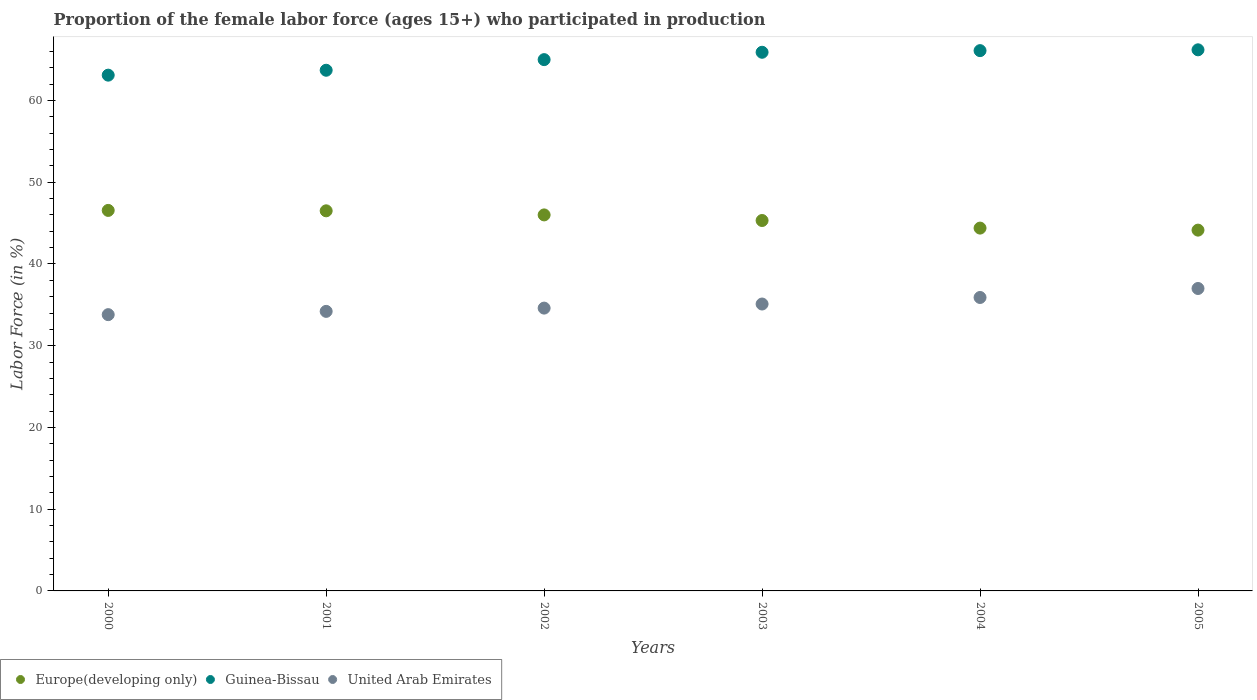What is the proportion of the female labor force who participated in production in Europe(developing only) in 2003?
Offer a terse response. 45.32. Across all years, what is the maximum proportion of the female labor force who participated in production in Europe(developing only)?
Give a very brief answer. 46.55. Across all years, what is the minimum proportion of the female labor force who participated in production in Europe(developing only)?
Make the answer very short. 44.14. In which year was the proportion of the female labor force who participated in production in Guinea-Bissau maximum?
Offer a very short reply. 2005. In which year was the proportion of the female labor force who participated in production in Guinea-Bissau minimum?
Ensure brevity in your answer.  2000. What is the total proportion of the female labor force who participated in production in Europe(developing only) in the graph?
Offer a very short reply. 272.9. What is the difference between the proportion of the female labor force who participated in production in Guinea-Bissau in 2003 and that in 2004?
Provide a succinct answer. -0.2. What is the difference between the proportion of the female labor force who participated in production in Europe(developing only) in 2004 and the proportion of the female labor force who participated in production in Guinea-Bissau in 2005?
Your answer should be very brief. -21.81. What is the average proportion of the female labor force who participated in production in Europe(developing only) per year?
Your answer should be very brief. 45.48. In the year 2002, what is the difference between the proportion of the female labor force who participated in production in Guinea-Bissau and proportion of the female labor force who participated in production in Europe(developing only)?
Offer a very short reply. 19. What is the ratio of the proportion of the female labor force who participated in production in Europe(developing only) in 2002 to that in 2003?
Your answer should be very brief. 1.02. Is the difference between the proportion of the female labor force who participated in production in Guinea-Bissau in 2002 and 2004 greater than the difference between the proportion of the female labor force who participated in production in Europe(developing only) in 2002 and 2004?
Your answer should be very brief. No. What is the difference between the highest and the second highest proportion of the female labor force who participated in production in Europe(developing only)?
Provide a short and direct response. 0.05. What is the difference between the highest and the lowest proportion of the female labor force who participated in production in Guinea-Bissau?
Your answer should be compact. 3.1. Is the sum of the proportion of the female labor force who participated in production in Guinea-Bissau in 2003 and 2005 greater than the maximum proportion of the female labor force who participated in production in United Arab Emirates across all years?
Give a very brief answer. Yes. Is it the case that in every year, the sum of the proportion of the female labor force who participated in production in Europe(developing only) and proportion of the female labor force who participated in production in Guinea-Bissau  is greater than the proportion of the female labor force who participated in production in United Arab Emirates?
Ensure brevity in your answer.  Yes. Is the proportion of the female labor force who participated in production in Guinea-Bissau strictly greater than the proportion of the female labor force who participated in production in Europe(developing only) over the years?
Offer a very short reply. Yes. How many dotlines are there?
Provide a succinct answer. 3. What is the difference between two consecutive major ticks on the Y-axis?
Your response must be concise. 10. Are the values on the major ticks of Y-axis written in scientific E-notation?
Keep it short and to the point. No. Does the graph contain any zero values?
Provide a short and direct response. No. Where does the legend appear in the graph?
Make the answer very short. Bottom left. What is the title of the graph?
Offer a terse response. Proportion of the female labor force (ages 15+) who participated in production. What is the Labor Force (in %) in Europe(developing only) in 2000?
Your answer should be very brief. 46.55. What is the Labor Force (in %) of Guinea-Bissau in 2000?
Your answer should be very brief. 63.1. What is the Labor Force (in %) of United Arab Emirates in 2000?
Your answer should be compact. 33.8. What is the Labor Force (in %) of Europe(developing only) in 2001?
Keep it short and to the point. 46.5. What is the Labor Force (in %) in Guinea-Bissau in 2001?
Offer a terse response. 63.7. What is the Labor Force (in %) of United Arab Emirates in 2001?
Keep it short and to the point. 34.2. What is the Labor Force (in %) in Europe(developing only) in 2002?
Give a very brief answer. 46. What is the Labor Force (in %) in United Arab Emirates in 2002?
Your answer should be compact. 34.6. What is the Labor Force (in %) in Europe(developing only) in 2003?
Ensure brevity in your answer.  45.32. What is the Labor Force (in %) of Guinea-Bissau in 2003?
Offer a very short reply. 65.9. What is the Labor Force (in %) of United Arab Emirates in 2003?
Ensure brevity in your answer.  35.1. What is the Labor Force (in %) in Europe(developing only) in 2004?
Your answer should be very brief. 44.39. What is the Labor Force (in %) in Guinea-Bissau in 2004?
Your answer should be very brief. 66.1. What is the Labor Force (in %) of United Arab Emirates in 2004?
Provide a short and direct response. 35.9. What is the Labor Force (in %) in Europe(developing only) in 2005?
Keep it short and to the point. 44.14. What is the Labor Force (in %) in Guinea-Bissau in 2005?
Offer a very short reply. 66.2. Across all years, what is the maximum Labor Force (in %) in Europe(developing only)?
Your response must be concise. 46.55. Across all years, what is the maximum Labor Force (in %) in Guinea-Bissau?
Make the answer very short. 66.2. Across all years, what is the maximum Labor Force (in %) in United Arab Emirates?
Your answer should be compact. 37. Across all years, what is the minimum Labor Force (in %) in Europe(developing only)?
Provide a short and direct response. 44.14. Across all years, what is the minimum Labor Force (in %) of Guinea-Bissau?
Ensure brevity in your answer.  63.1. Across all years, what is the minimum Labor Force (in %) of United Arab Emirates?
Your answer should be compact. 33.8. What is the total Labor Force (in %) of Europe(developing only) in the graph?
Make the answer very short. 272.9. What is the total Labor Force (in %) of Guinea-Bissau in the graph?
Offer a terse response. 390. What is the total Labor Force (in %) of United Arab Emirates in the graph?
Keep it short and to the point. 210.6. What is the difference between the Labor Force (in %) of Europe(developing only) in 2000 and that in 2001?
Provide a succinct answer. 0.05. What is the difference between the Labor Force (in %) in Guinea-Bissau in 2000 and that in 2001?
Make the answer very short. -0.6. What is the difference between the Labor Force (in %) of United Arab Emirates in 2000 and that in 2001?
Provide a succinct answer. -0.4. What is the difference between the Labor Force (in %) of Europe(developing only) in 2000 and that in 2002?
Ensure brevity in your answer.  0.55. What is the difference between the Labor Force (in %) of Europe(developing only) in 2000 and that in 2003?
Offer a very short reply. 1.24. What is the difference between the Labor Force (in %) of Europe(developing only) in 2000 and that in 2004?
Offer a very short reply. 2.16. What is the difference between the Labor Force (in %) in United Arab Emirates in 2000 and that in 2004?
Ensure brevity in your answer.  -2.1. What is the difference between the Labor Force (in %) in Europe(developing only) in 2000 and that in 2005?
Ensure brevity in your answer.  2.41. What is the difference between the Labor Force (in %) in Guinea-Bissau in 2000 and that in 2005?
Keep it short and to the point. -3.1. What is the difference between the Labor Force (in %) of Europe(developing only) in 2001 and that in 2002?
Your answer should be compact. 0.5. What is the difference between the Labor Force (in %) in Guinea-Bissau in 2001 and that in 2002?
Keep it short and to the point. -1.3. What is the difference between the Labor Force (in %) in United Arab Emirates in 2001 and that in 2002?
Offer a very short reply. -0.4. What is the difference between the Labor Force (in %) in Europe(developing only) in 2001 and that in 2003?
Provide a succinct answer. 1.19. What is the difference between the Labor Force (in %) of Guinea-Bissau in 2001 and that in 2003?
Provide a succinct answer. -2.2. What is the difference between the Labor Force (in %) in Europe(developing only) in 2001 and that in 2004?
Offer a very short reply. 2.11. What is the difference between the Labor Force (in %) of United Arab Emirates in 2001 and that in 2004?
Provide a succinct answer. -1.7. What is the difference between the Labor Force (in %) in Europe(developing only) in 2001 and that in 2005?
Give a very brief answer. 2.36. What is the difference between the Labor Force (in %) of United Arab Emirates in 2001 and that in 2005?
Offer a very short reply. -2.8. What is the difference between the Labor Force (in %) of Europe(developing only) in 2002 and that in 2003?
Your response must be concise. 0.69. What is the difference between the Labor Force (in %) of Europe(developing only) in 2002 and that in 2004?
Your answer should be compact. 1.61. What is the difference between the Labor Force (in %) of Guinea-Bissau in 2002 and that in 2004?
Give a very brief answer. -1.1. What is the difference between the Labor Force (in %) in United Arab Emirates in 2002 and that in 2004?
Provide a short and direct response. -1.3. What is the difference between the Labor Force (in %) in Europe(developing only) in 2002 and that in 2005?
Keep it short and to the point. 1.86. What is the difference between the Labor Force (in %) in Guinea-Bissau in 2002 and that in 2005?
Provide a succinct answer. -1.2. What is the difference between the Labor Force (in %) in Europe(developing only) in 2003 and that in 2004?
Your answer should be very brief. 0.93. What is the difference between the Labor Force (in %) of Guinea-Bissau in 2003 and that in 2004?
Your answer should be very brief. -0.2. What is the difference between the Labor Force (in %) of United Arab Emirates in 2003 and that in 2004?
Offer a very short reply. -0.8. What is the difference between the Labor Force (in %) of Europe(developing only) in 2003 and that in 2005?
Your answer should be compact. 1.18. What is the difference between the Labor Force (in %) of Europe(developing only) in 2004 and that in 2005?
Provide a short and direct response. 0.25. What is the difference between the Labor Force (in %) in Guinea-Bissau in 2004 and that in 2005?
Provide a short and direct response. -0.1. What is the difference between the Labor Force (in %) in Europe(developing only) in 2000 and the Labor Force (in %) in Guinea-Bissau in 2001?
Provide a short and direct response. -17.15. What is the difference between the Labor Force (in %) of Europe(developing only) in 2000 and the Labor Force (in %) of United Arab Emirates in 2001?
Your answer should be compact. 12.35. What is the difference between the Labor Force (in %) in Guinea-Bissau in 2000 and the Labor Force (in %) in United Arab Emirates in 2001?
Offer a very short reply. 28.9. What is the difference between the Labor Force (in %) in Europe(developing only) in 2000 and the Labor Force (in %) in Guinea-Bissau in 2002?
Keep it short and to the point. -18.45. What is the difference between the Labor Force (in %) in Europe(developing only) in 2000 and the Labor Force (in %) in United Arab Emirates in 2002?
Ensure brevity in your answer.  11.95. What is the difference between the Labor Force (in %) of Guinea-Bissau in 2000 and the Labor Force (in %) of United Arab Emirates in 2002?
Provide a succinct answer. 28.5. What is the difference between the Labor Force (in %) in Europe(developing only) in 2000 and the Labor Force (in %) in Guinea-Bissau in 2003?
Give a very brief answer. -19.35. What is the difference between the Labor Force (in %) of Europe(developing only) in 2000 and the Labor Force (in %) of United Arab Emirates in 2003?
Keep it short and to the point. 11.45. What is the difference between the Labor Force (in %) in Europe(developing only) in 2000 and the Labor Force (in %) in Guinea-Bissau in 2004?
Provide a short and direct response. -19.55. What is the difference between the Labor Force (in %) in Europe(developing only) in 2000 and the Labor Force (in %) in United Arab Emirates in 2004?
Offer a very short reply. 10.65. What is the difference between the Labor Force (in %) in Guinea-Bissau in 2000 and the Labor Force (in %) in United Arab Emirates in 2004?
Your response must be concise. 27.2. What is the difference between the Labor Force (in %) in Europe(developing only) in 2000 and the Labor Force (in %) in Guinea-Bissau in 2005?
Make the answer very short. -19.65. What is the difference between the Labor Force (in %) in Europe(developing only) in 2000 and the Labor Force (in %) in United Arab Emirates in 2005?
Keep it short and to the point. 9.55. What is the difference between the Labor Force (in %) in Guinea-Bissau in 2000 and the Labor Force (in %) in United Arab Emirates in 2005?
Provide a succinct answer. 26.1. What is the difference between the Labor Force (in %) in Europe(developing only) in 2001 and the Labor Force (in %) in Guinea-Bissau in 2002?
Your answer should be very brief. -18.5. What is the difference between the Labor Force (in %) of Europe(developing only) in 2001 and the Labor Force (in %) of United Arab Emirates in 2002?
Provide a short and direct response. 11.9. What is the difference between the Labor Force (in %) in Guinea-Bissau in 2001 and the Labor Force (in %) in United Arab Emirates in 2002?
Provide a succinct answer. 29.1. What is the difference between the Labor Force (in %) of Europe(developing only) in 2001 and the Labor Force (in %) of Guinea-Bissau in 2003?
Make the answer very short. -19.4. What is the difference between the Labor Force (in %) in Europe(developing only) in 2001 and the Labor Force (in %) in United Arab Emirates in 2003?
Your answer should be compact. 11.4. What is the difference between the Labor Force (in %) in Guinea-Bissau in 2001 and the Labor Force (in %) in United Arab Emirates in 2003?
Offer a terse response. 28.6. What is the difference between the Labor Force (in %) of Europe(developing only) in 2001 and the Labor Force (in %) of Guinea-Bissau in 2004?
Your answer should be very brief. -19.6. What is the difference between the Labor Force (in %) of Europe(developing only) in 2001 and the Labor Force (in %) of United Arab Emirates in 2004?
Make the answer very short. 10.6. What is the difference between the Labor Force (in %) of Guinea-Bissau in 2001 and the Labor Force (in %) of United Arab Emirates in 2004?
Your response must be concise. 27.8. What is the difference between the Labor Force (in %) in Europe(developing only) in 2001 and the Labor Force (in %) in Guinea-Bissau in 2005?
Offer a very short reply. -19.7. What is the difference between the Labor Force (in %) in Europe(developing only) in 2001 and the Labor Force (in %) in United Arab Emirates in 2005?
Offer a very short reply. 9.5. What is the difference between the Labor Force (in %) of Guinea-Bissau in 2001 and the Labor Force (in %) of United Arab Emirates in 2005?
Give a very brief answer. 26.7. What is the difference between the Labor Force (in %) in Europe(developing only) in 2002 and the Labor Force (in %) in Guinea-Bissau in 2003?
Provide a short and direct response. -19.9. What is the difference between the Labor Force (in %) of Europe(developing only) in 2002 and the Labor Force (in %) of United Arab Emirates in 2003?
Provide a succinct answer. 10.9. What is the difference between the Labor Force (in %) in Guinea-Bissau in 2002 and the Labor Force (in %) in United Arab Emirates in 2003?
Your response must be concise. 29.9. What is the difference between the Labor Force (in %) in Europe(developing only) in 2002 and the Labor Force (in %) in Guinea-Bissau in 2004?
Make the answer very short. -20.1. What is the difference between the Labor Force (in %) of Europe(developing only) in 2002 and the Labor Force (in %) of United Arab Emirates in 2004?
Offer a terse response. 10.1. What is the difference between the Labor Force (in %) in Guinea-Bissau in 2002 and the Labor Force (in %) in United Arab Emirates in 2004?
Make the answer very short. 29.1. What is the difference between the Labor Force (in %) of Europe(developing only) in 2002 and the Labor Force (in %) of Guinea-Bissau in 2005?
Offer a very short reply. -20.2. What is the difference between the Labor Force (in %) of Europe(developing only) in 2002 and the Labor Force (in %) of United Arab Emirates in 2005?
Give a very brief answer. 9. What is the difference between the Labor Force (in %) in Guinea-Bissau in 2002 and the Labor Force (in %) in United Arab Emirates in 2005?
Provide a succinct answer. 28. What is the difference between the Labor Force (in %) of Europe(developing only) in 2003 and the Labor Force (in %) of Guinea-Bissau in 2004?
Your response must be concise. -20.78. What is the difference between the Labor Force (in %) of Europe(developing only) in 2003 and the Labor Force (in %) of United Arab Emirates in 2004?
Offer a terse response. 9.42. What is the difference between the Labor Force (in %) in Guinea-Bissau in 2003 and the Labor Force (in %) in United Arab Emirates in 2004?
Provide a short and direct response. 30. What is the difference between the Labor Force (in %) in Europe(developing only) in 2003 and the Labor Force (in %) in Guinea-Bissau in 2005?
Offer a terse response. -20.88. What is the difference between the Labor Force (in %) of Europe(developing only) in 2003 and the Labor Force (in %) of United Arab Emirates in 2005?
Ensure brevity in your answer.  8.32. What is the difference between the Labor Force (in %) in Guinea-Bissau in 2003 and the Labor Force (in %) in United Arab Emirates in 2005?
Your response must be concise. 28.9. What is the difference between the Labor Force (in %) of Europe(developing only) in 2004 and the Labor Force (in %) of Guinea-Bissau in 2005?
Give a very brief answer. -21.81. What is the difference between the Labor Force (in %) of Europe(developing only) in 2004 and the Labor Force (in %) of United Arab Emirates in 2005?
Provide a succinct answer. 7.39. What is the difference between the Labor Force (in %) in Guinea-Bissau in 2004 and the Labor Force (in %) in United Arab Emirates in 2005?
Keep it short and to the point. 29.1. What is the average Labor Force (in %) in Europe(developing only) per year?
Offer a terse response. 45.48. What is the average Labor Force (in %) of Guinea-Bissau per year?
Make the answer very short. 65. What is the average Labor Force (in %) of United Arab Emirates per year?
Keep it short and to the point. 35.1. In the year 2000, what is the difference between the Labor Force (in %) of Europe(developing only) and Labor Force (in %) of Guinea-Bissau?
Your response must be concise. -16.55. In the year 2000, what is the difference between the Labor Force (in %) in Europe(developing only) and Labor Force (in %) in United Arab Emirates?
Offer a terse response. 12.75. In the year 2000, what is the difference between the Labor Force (in %) of Guinea-Bissau and Labor Force (in %) of United Arab Emirates?
Offer a very short reply. 29.3. In the year 2001, what is the difference between the Labor Force (in %) in Europe(developing only) and Labor Force (in %) in Guinea-Bissau?
Give a very brief answer. -17.2. In the year 2001, what is the difference between the Labor Force (in %) in Europe(developing only) and Labor Force (in %) in United Arab Emirates?
Your answer should be very brief. 12.3. In the year 2001, what is the difference between the Labor Force (in %) of Guinea-Bissau and Labor Force (in %) of United Arab Emirates?
Offer a very short reply. 29.5. In the year 2002, what is the difference between the Labor Force (in %) in Europe(developing only) and Labor Force (in %) in Guinea-Bissau?
Keep it short and to the point. -19. In the year 2002, what is the difference between the Labor Force (in %) of Europe(developing only) and Labor Force (in %) of United Arab Emirates?
Provide a short and direct response. 11.4. In the year 2002, what is the difference between the Labor Force (in %) of Guinea-Bissau and Labor Force (in %) of United Arab Emirates?
Offer a terse response. 30.4. In the year 2003, what is the difference between the Labor Force (in %) in Europe(developing only) and Labor Force (in %) in Guinea-Bissau?
Offer a very short reply. -20.58. In the year 2003, what is the difference between the Labor Force (in %) in Europe(developing only) and Labor Force (in %) in United Arab Emirates?
Provide a succinct answer. 10.22. In the year 2003, what is the difference between the Labor Force (in %) of Guinea-Bissau and Labor Force (in %) of United Arab Emirates?
Provide a succinct answer. 30.8. In the year 2004, what is the difference between the Labor Force (in %) of Europe(developing only) and Labor Force (in %) of Guinea-Bissau?
Your answer should be compact. -21.71. In the year 2004, what is the difference between the Labor Force (in %) of Europe(developing only) and Labor Force (in %) of United Arab Emirates?
Offer a very short reply. 8.49. In the year 2004, what is the difference between the Labor Force (in %) of Guinea-Bissau and Labor Force (in %) of United Arab Emirates?
Make the answer very short. 30.2. In the year 2005, what is the difference between the Labor Force (in %) in Europe(developing only) and Labor Force (in %) in Guinea-Bissau?
Make the answer very short. -22.06. In the year 2005, what is the difference between the Labor Force (in %) of Europe(developing only) and Labor Force (in %) of United Arab Emirates?
Provide a succinct answer. 7.14. In the year 2005, what is the difference between the Labor Force (in %) of Guinea-Bissau and Labor Force (in %) of United Arab Emirates?
Ensure brevity in your answer.  29.2. What is the ratio of the Labor Force (in %) in Europe(developing only) in 2000 to that in 2001?
Ensure brevity in your answer.  1. What is the ratio of the Labor Force (in %) of Guinea-Bissau in 2000 to that in 2001?
Keep it short and to the point. 0.99. What is the ratio of the Labor Force (in %) in United Arab Emirates in 2000 to that in 2001?
Give a very brief answer. 0.99. What is the ratio of the Labor Force (in %) of Guinea-Bissau in 2000 to that in 2002?
Provide a succinct answer. 0.97. What is the ratio of the Labor Force (in %) of United Arab Emirates in 2000 to that in 2002?
Ensure brevity in your answer.  0.98. What is the ratio of the Labor Force (in %) of Europe(developing only) in 2000 to that in 2003?
Ensure brevity in your answer.  1.03. What is the ratio of the Labor Force (in %) in Guinea-Bissau in 2000 to that in 2003?
Ensure brevity in your answer.  0.96. What is the ratio of the Labor Force (in %) in United Arab Emirates in 2000 to that in 2003?
Your answer should be compact. 0.96. What is the ratio of the Labor Force (in %) in Europe(developing only) in 2000 to that in 2004?
Your response must be concise. 1.05. What is the ratio of the Labor Force (in %) in Guinea-Bissau in 2000 to that in 2004?
Offer a terse response. 0.95. What is the ratio of the Labor Force (in %) of United Arab Emirates in 2000 to that in 2004?
Your response must be concise. 0.94. What is the ratio of the Labor Force (in %) in Europe(developing only) in 2000 to that in 2005?
Your answer should be very brief. 1.05. What is the ratio of the Labor Force (in %) in Guinea-Bissau in 2000 to that in 2005?
Provide a short and direct response. 0.95. What is the ratio of the Labor Force (in %) in United Arab Emirates in 2000 to that in 2005?
Offer a terse response. 0.91. What is the ratio of the Labor Force (in %) in Europe(developing only) in 2001 to that in 2002?
Offer a terse response. 1.01. What is the ratio of the Labor Force (in %) of United Arab Emirates in 2001 to that in 2002?
Offer a very short reply. 0.99. What is the ratio of the Labor Force (in %) of Europe(developing only) in 2001 to that in 2003?
Your response must be concise. 1.03. What is the ratio of the Labor Force (in %) in Guinea-Bissau in 2001 to that in 2003?
Offer a terse response. 0.97. What is the ratio of the Labor Force (in %) of United Arab Emirates in 2001 to that in 2003?
Ensure brevity in your answer.  0.97. What is the ratio of the Labor Force (in %) of Europe(developing only) in 2001 to that in 2004?
Your response must be concise. 1.05. What is the ratio of the Labor Force (in %) of Guinea-Bissau in 2001 to that in 2004?
Make the answer very short. 0.96. What is the ratio of the Labor Force (in %) in United Arab Emirates in 2001 to that in 2004?
Provide a succinct answer. 0.95. What is the ratio of the Labor Force (in %) in Europe(developing only) in 2001 to that in 2005?
Keep it short and to the point. 1.05. What is the ratio of the Labor Force (in %) in Guinea-Bissau in 2001 to that in 2005?
Offer a terse response. 0.96. What is the ratio of the Labor Force (in %) of United Arab Emirates in 2001 to that in 2005?
Keep it short and to the point. 0.92. What is the ratio of the Labor Force (in %) of Europe(developing only) in 2002 to that in 2003?
Your answer should be very brief. 1.02. What is the ratio of the Labor Force (in %) in Guinea-Bissau in 2002 to that in 2003?
Keep it short and to the point. 0.99. What is the ratio of the Labor Force (in %) in United Arab Emirates in 2002 to that in 2003?
Ensure brevity in your answer.  0.99. What is the ratio of the Labor Force (in %) in Europe(developing only) in 2002 to that in 2004?
Make the answer very short. 1.04. What is the ratio of the Labor Force (in %) of Guinea-Bissau in 2002 to that in 2004?
Offer a very short reply. 0.98. What is the ratio of the Labor Force (in %) of United Arab Emirates in 2002 to that in 2004?
Make the answer very short. 0.96. What is the ratio of the Labor Force (in %) in Europe(developing only) in 2002 to that in 2005?
Your response must be concise. 1.04. What is the ratio of the Labor Force (in %) of Guinea-Bissau in 2002 to that in 2005?
Provide a succinct answer. 0.98. What is the ratio of the Labor Force (in %) in United Arab Emirates in 2002 to that in 2005?
Provide a short and direct response. 0.94. What is the ratio of the Labor Force (in %) of Europe(developing only) in 2003 to that in 2004?
Make the answer very short. 1.02. What is the ratio of the Labor Force (in %) of United Arab Emirates in 2003 to that in 2004?
Provide a short and direct response. 0.98. What is the ratio of the Labor Force (in %) in Europe(developing only) in 2003 to that in 2005?
Keep it short and to the point. 1.03. What is the ratio of the Labor Force (in %) in United Arab Emirates in 2003 to that in 2005?
Provide a succinct answer. 0.95. What is the ratio of the Labor Force (in %) of Europe(developing only) in 2004 to that in 2005?
Give a very brief answer. 1.01. What is the ratio of the Labor Force (in %) in United Arab Emirates in 2004 to that in 2005?
Offer a very short reply. 0.97. What is the difference between the highest and the second highest Labor Force (in %) in United Arab Emirates?
Ensure brevity in your answer.  1.1. What is the difference between the highest and the lowest Labor Force (in %) in Europe(developing only)?
Offer a very short reply. 2.41. What is the difference between the highest and the lowest Labor Force (in %) in Guinea-Bissau?
Give a very brief answer. 3.1. 